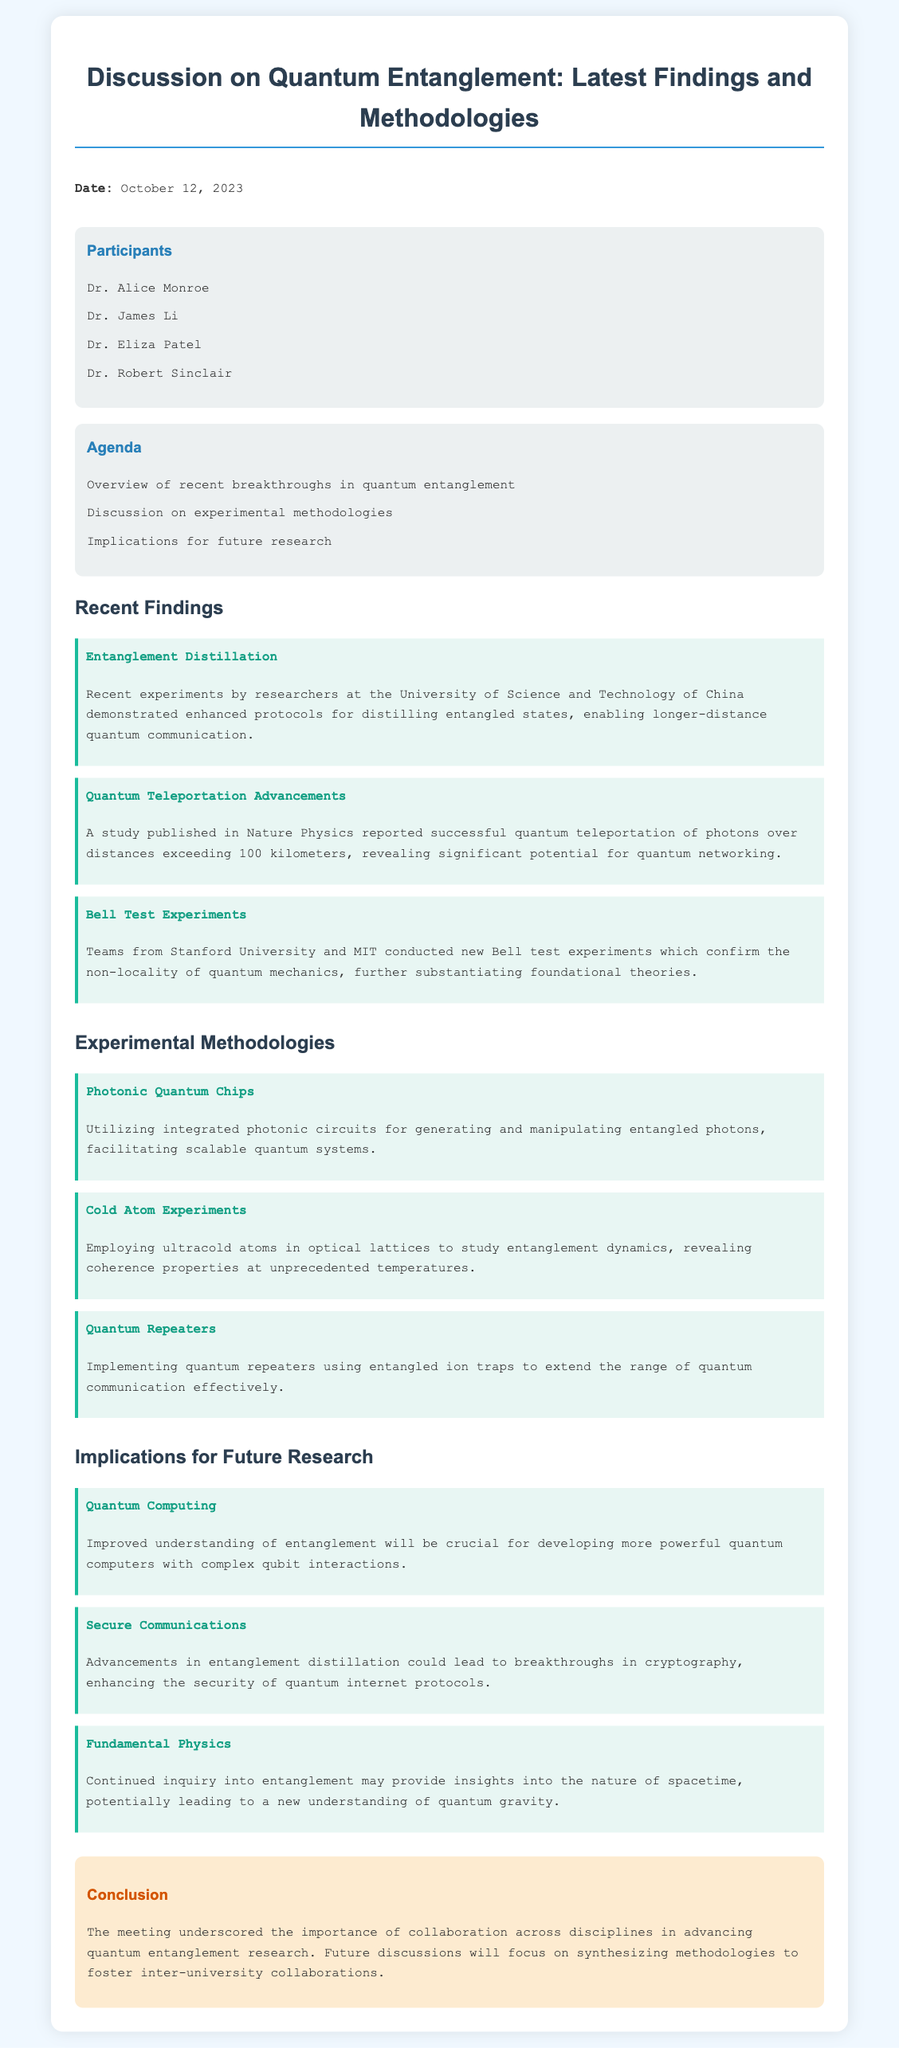What is the date of the meeting? The date of the meeting is explicitly stated in the document under the meta-info section.
Answer: October 12, 2023 Who reported on quantum teleportation advancements? The document mentions a study published in Nature Physics regarding quantum teleportation advancements.
Answer: Nature Physics What experimental methodology uses integrated photonic circuits? The discussion section on experimental methodologies explains the use of photonic quantum chips for this purpose.
Answer: Photonic Quantum Chips Which university conducted the Bell test experiments? The meeting minutes specify that Stanford University and MIT conducted the new Bell test experiments.
Answer: Stanford University and MIT What is one implication for future research related to secure communications? The implications section articulates how advancements in entanglement distillation could enhance security in quantum communications.
Answer: Enhancing the security of quantum internet protocols What were the participants encouraged to do in the conclusion section? The conclusion indicates the importance of collaboration across disciplines to advance research.
Answer: Collaboration across disciplines What type of experiments use ultracold atoms? The document highlights cold atom experiments as a methodology for studying entanglement dynamics.
Answer: Cold Atom Experiments 